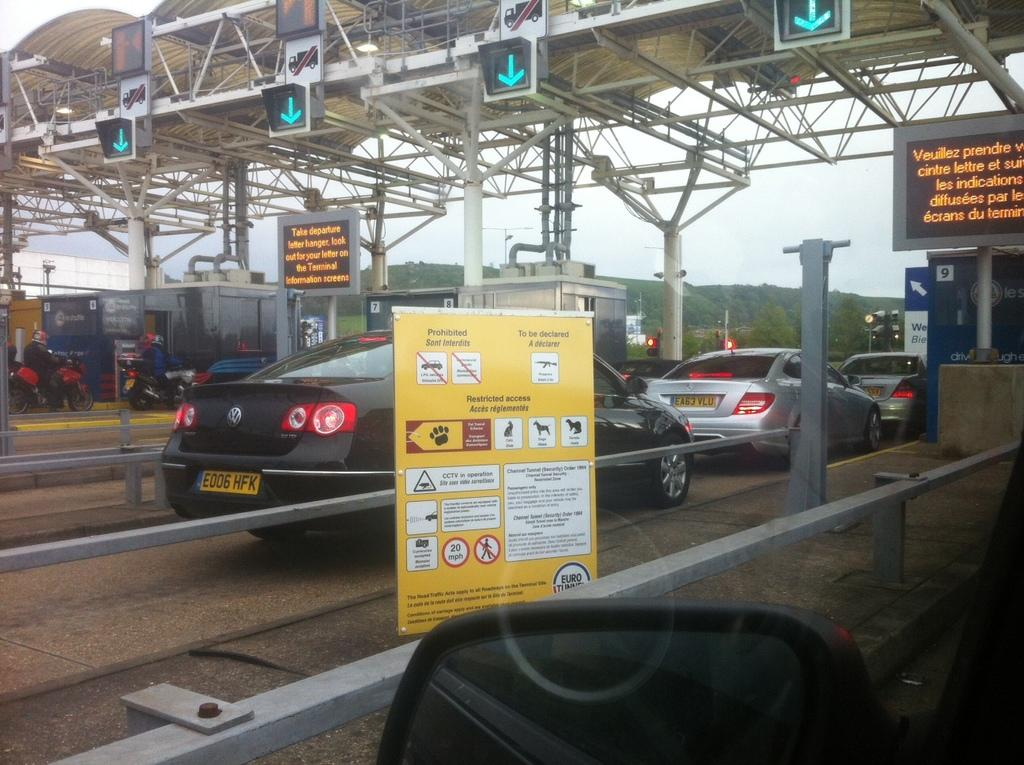<image>
Relay a brief, clear account of the picture shown. A check point for departure terminals to drive cars through. 